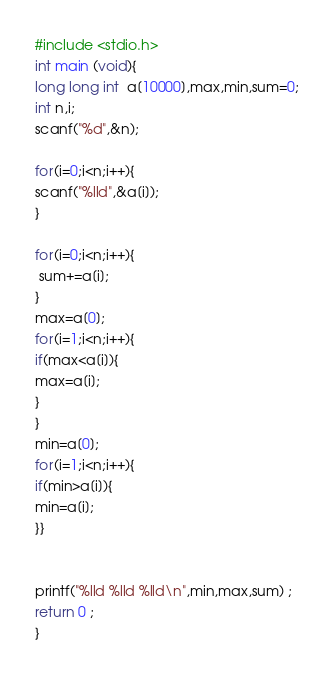Convert code to text. <code><loc_0><loc_0><loc_500><loc_500><_C_>
#include <stdio.h>
int main (void){
long long int  a[10000],max,min,sum=0;
int n,i;
scanf("%d",&n);

for(i=0;i<n;i++){
scanf("%lld",&a[i]);
}

for(i=0;i<n;i++){
 sum+=a[i];
}
max=a[0];
for(i=1;i<n;i++){
if(max<a[i]){
max=a[i];
}
}
min=a[0];
for(i=1;i<n;i++){
if(min>a[i]){
min=a[i];
}}


printf("%lld %lld %lld\n",min,max,sum) ;
return 0 ;
}</code> 